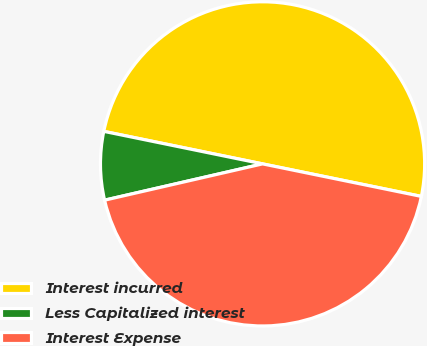Convert chart. <chart><loc_0><loc_0><loc_500><loc_500><pie_chart><fcel>Interest incurred<fcel>Less Capitalized interest<fcel>Interest Expense<nl><fcel>50.0%<fcel>6.81%<fcel>43.19%<nl></chart> 